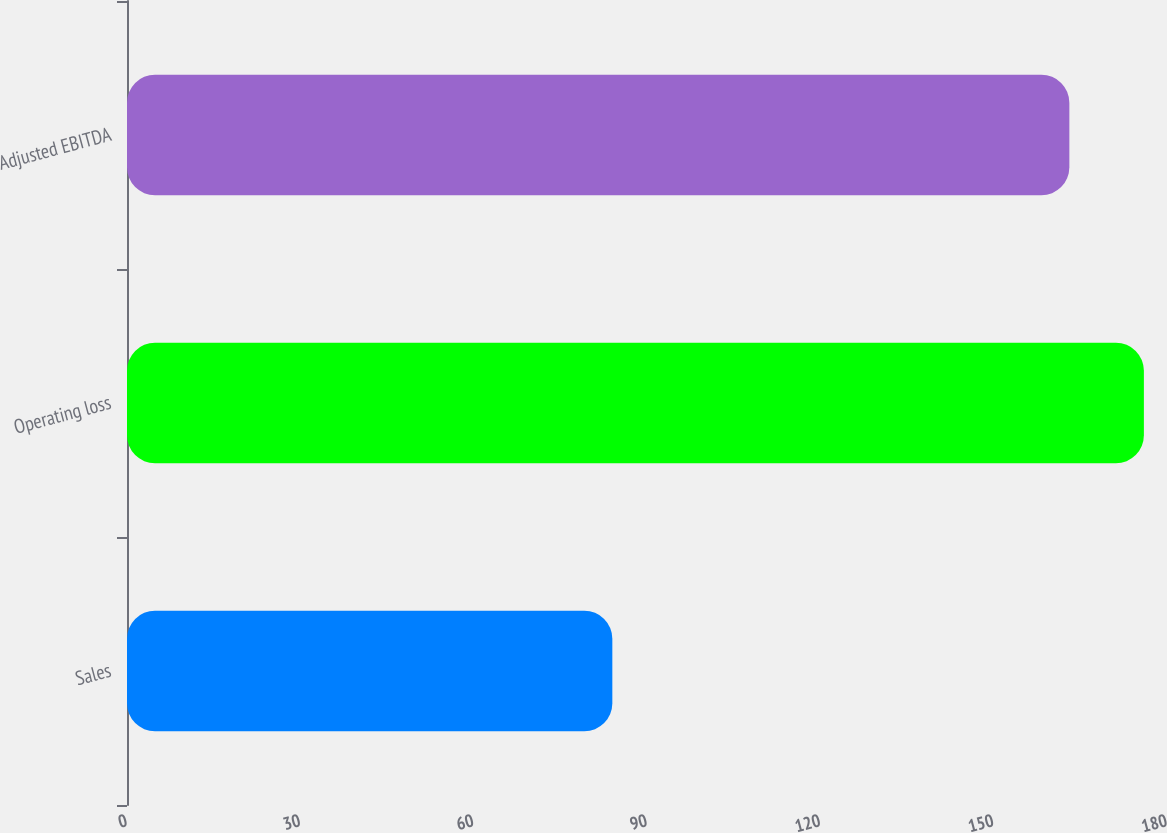Convert chart to OTSL. <chart><loc_0><loc_0><loc_500><loc_500><bar_chart><fcel>Sales<fcel>Operating loss<fcel>Adjusted EBITDA<nl><fcel>84<fcel>176<fcel>163.1<nl></chart> 